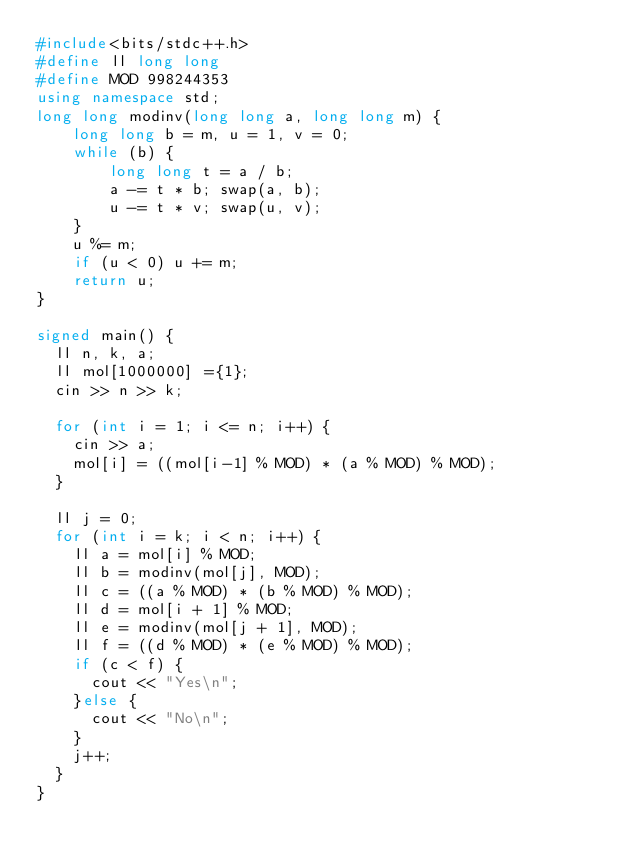<code> <loc_0><loc_0><loc_500><loc_500><_C++_>#include<bits/stdc++.h>
#define ll long long
#define MOD 998244353
using namespace std;
long long modinv(long long a, long long m) {
    long long b = m, u = 1, v = 0;
    while (b) {
        long long t = a / b;
        a -= t * b; swap(a, b);
        u -= t * v; swap(u, v);
    }
    u %= m;
    if (u < 0) u += m;
    return u;
}

signed main() {
  ll n, k, a;
  ll mol[1000000] ={1};
  cin >> n >> k;

  for (int i = 1; i <= n; i++) {
    cin >> a;
    mol[i] = ((mol[i-1] % MOD) * (a % MOD) % MOD);
  }

  ll j = 0;
  for (int i = k; i < n; i++) {
    ll a = mol[i] % MOD;
    ll b = modinv(mol[j], MOD);
    ll c = ((a % MOD) * (b % MOD) % MOD);
    ll d = mol[i + 1] % MOD;
    ll e = modinv(mol[j + 1], MOD);
    ll f = ((d % MOD) * (e % MOD) % MOD);
    if (c < f) {
      cout << "Yes\n";
    }else {
      cout << "No\n";
    }
    j++;
  }
}</code> 